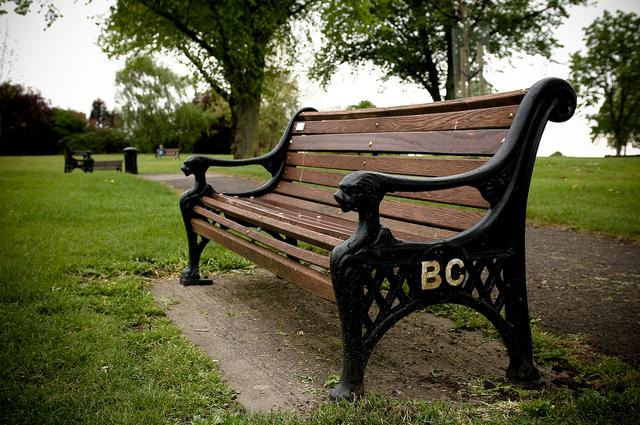What type of bench is this? Please explain your reasoning. park. The greenery and nature surrounding the bench indicate that it is in a pastoral setting. 